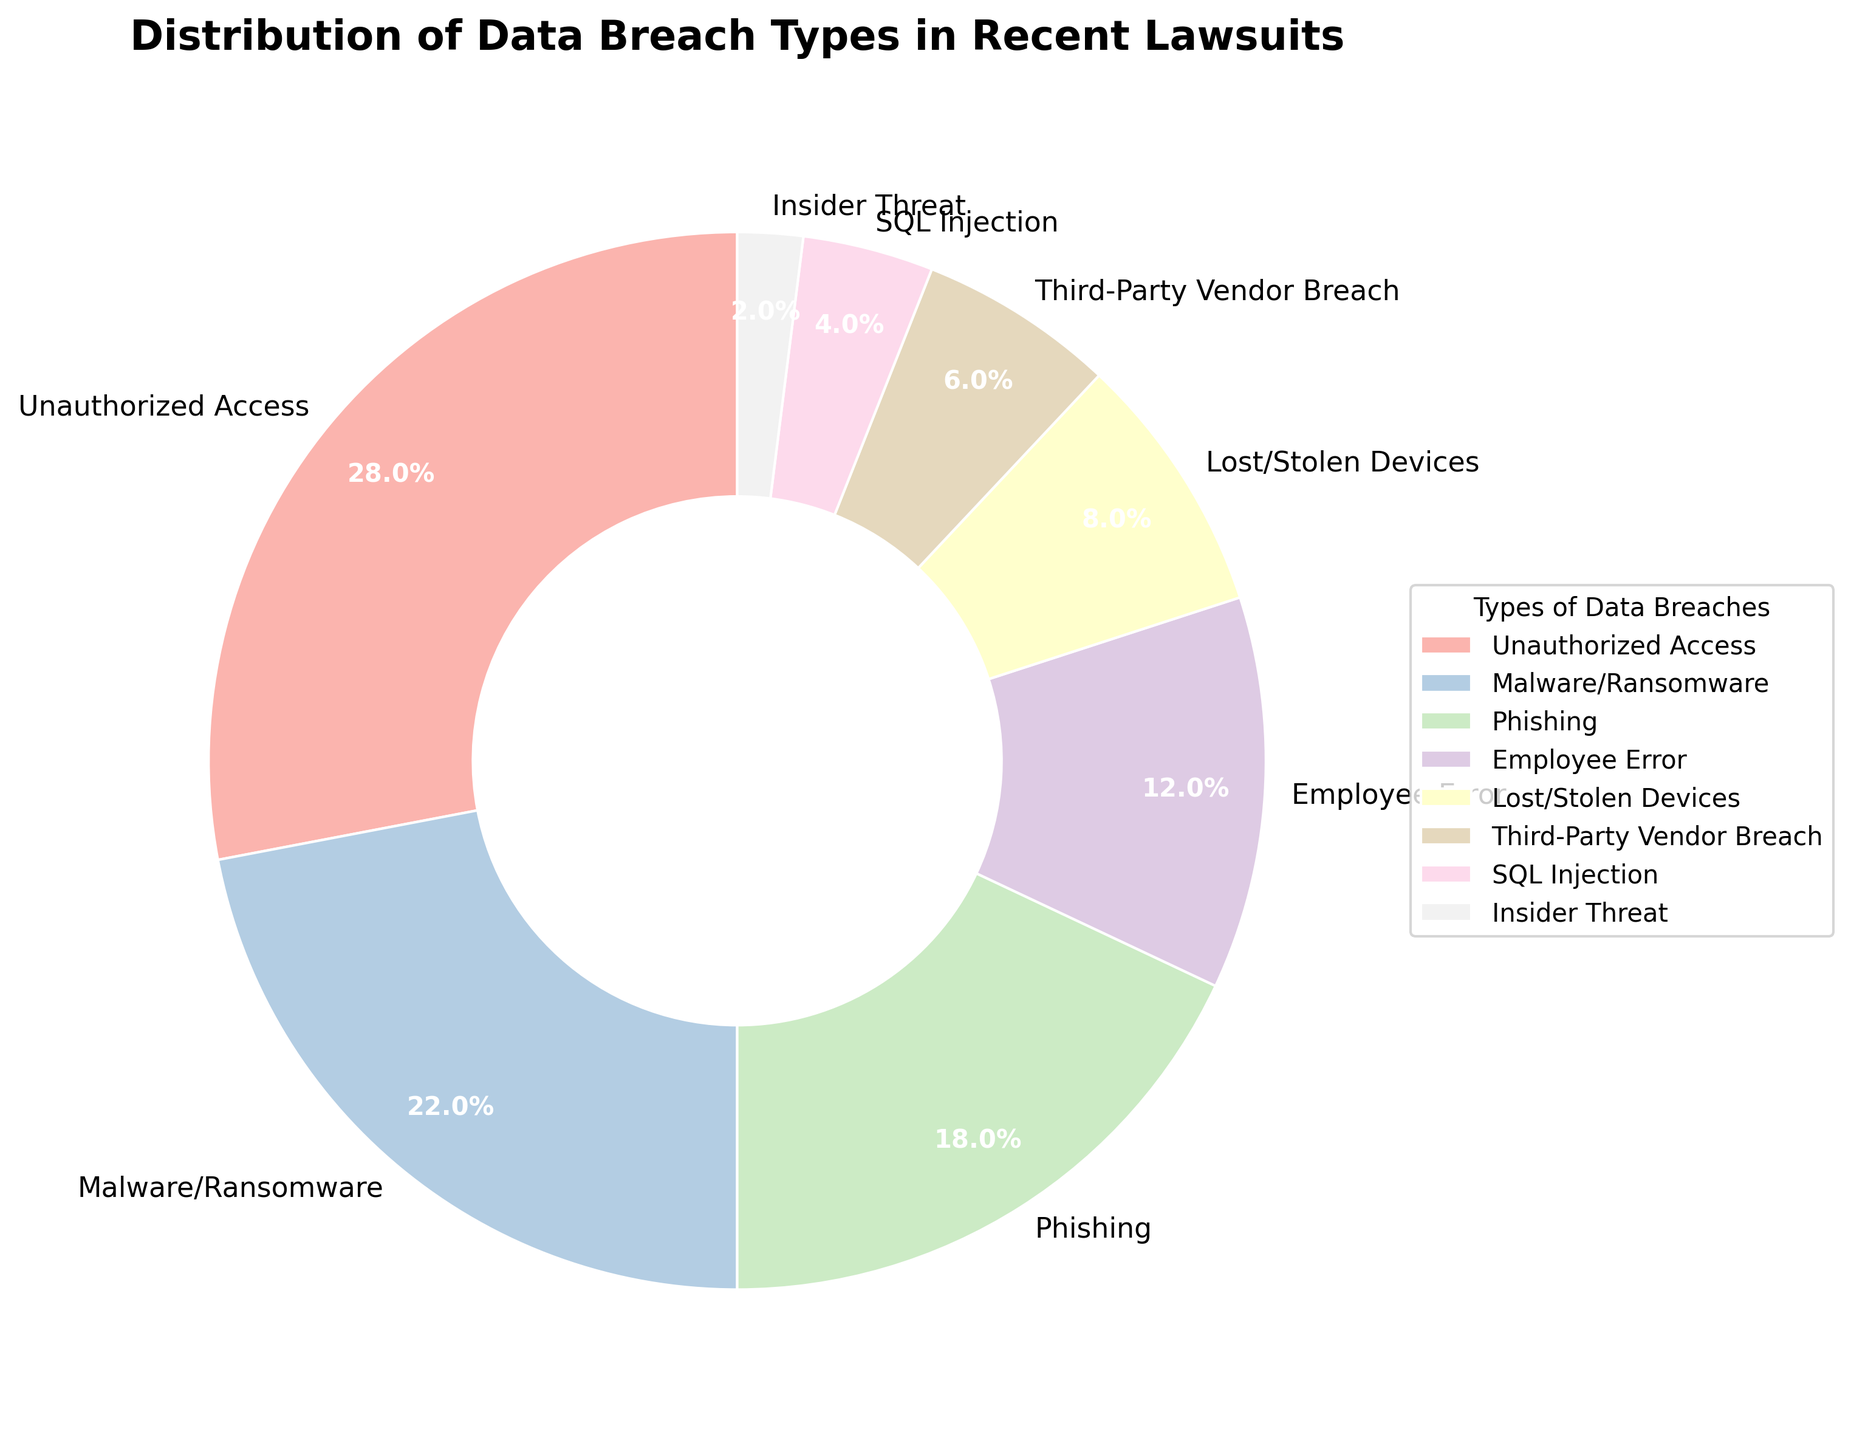What's the percentage of Unauthorized Access breaches? To find the percentage of Unauthorized Access breaches, locate the section labeled "Unauthorized Access" on the pie chart and refer to the percentage value shown within this section.
Answer: 28% Which type of data breach has the lowest percentage? Locate the smallest wedge in the pie chart and check its corresponding label to determine the type of breach. The label "Insider Threat" has the smallest wedge.
Answer: Insider Threat What is the combined percentage of Malware/Ransomware and Phishing breaches? Sum the percentages of the "Malware/Ransomware" and "Phishing" breaches from the pie chart. Malware/Ransomware is 22% and Phishing is 18%, so 22% + 18% = 40%.
Answer: 40% Which data breach type has a greater percentage: Employee Error or Lost/Stolen Devices? Compare the sizes of the "Employee Error" and "Lost/Stolen Devices" sections of the pie chart. "Employee Error" is 12% and "Lost/Stolen Devices" is 8%, so "Employee Error" has a greater percentage.
Answer: Employee Error How much higher is the percentage of Unauthorized Access compared to Third-Party Vendor Breach? Subtract the percentage of "Third-Party Vendor Breach" from the percentage of "Unauthorized Access". Unauthorized Access is 28% and Third-Party Vendor Breach is 6%, so 28% - 6% = 22%.
Answer: 22% What is the total percentage of breaches caused by human factors (Unauthorized Access, Employee Error, Insider Threat)? Sum the percentages of "Unauthorized Access", "Employee Error", and "Insider Threat" from the pie chart. Unauthorized Access is 28%, Employee Error is 12%, and Insider Threat is 2%, so 28% + 12% + 2% = 42%.
Answer: 42% Are there more breaches due to Phishing or Third-Party Vendor Breach? Compare the percentages of "Phishing" and "Third-Party Vendor Breach" sections in the pie chart. Phishing is 18% and Third-Party Vendor Breach is 6%, so there are more breaches due to Phishing.
Answer: Phishing 